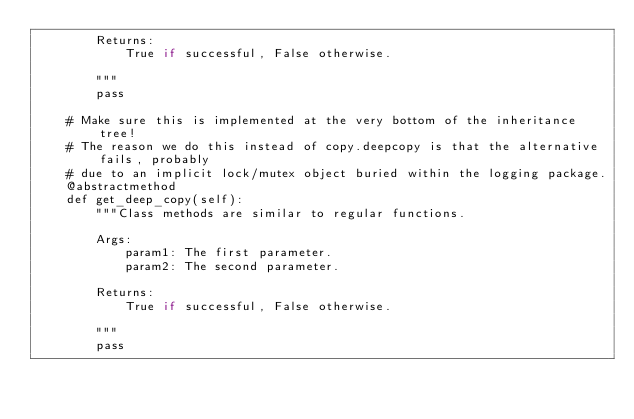Convert code to text. <code><loc_0><loc_0><loc_500><loc_500><_Python_>        Returns:
            True if successful, False otherwise.

        """        
        pass
    
    # Make sure this is implemented at the very bottom of the inheritance tree! 
    # The reason we do this instead of copy.deepcopy is that the alternative fails, probably 
    # due to an implicit lock/mutex object buried within the logging package.
    @abstractmethod
    def get_deep_copy(self):      
        """Class methods are similar to regular functions.

        Args:
            param1: The first parameter.
            param2: The second parameter.

        Returns:
            True if successful, False otherwise.

        """    
        pass

</code> 